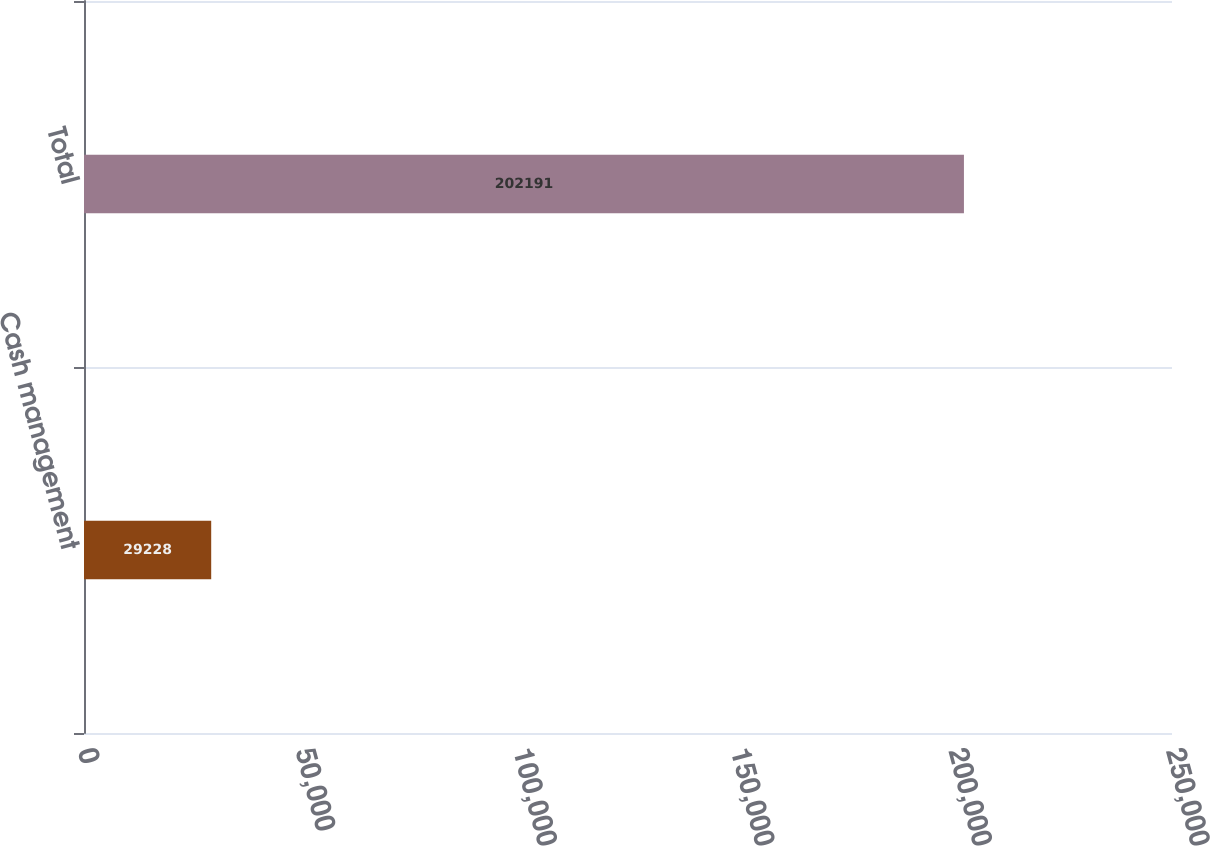Convert chart. <chart><loc_0><loc_0><loc_500><loc_500><bar_chart><fcel>Cash management<fcel>Total<nl><fcel>29228<fcel>202191<nl></chart> 